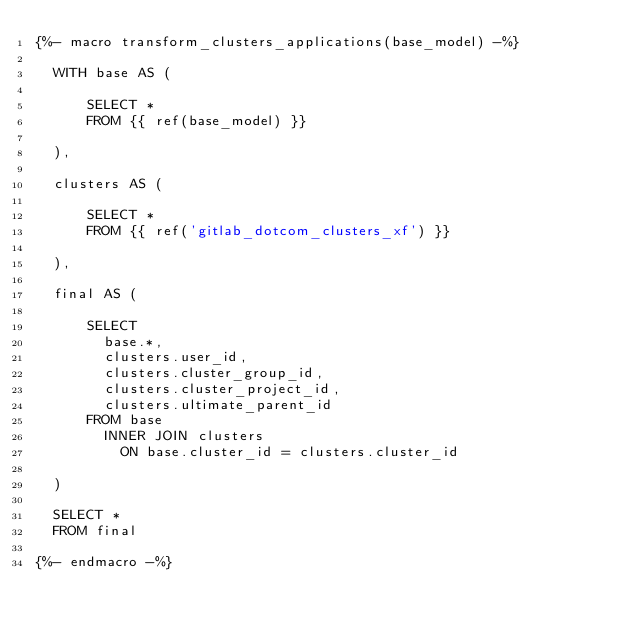Convert code to text. <code><loc_0><loc_0><loc_500><loc_500><_SQL_>{%- macro transform_clusters_applications(base_model) -%}

  WITH base AS (

      SELECT *
      FROM {{ ref(base_model) }}

  ),

  clusters AS (

      SELECT *
      FROM {{ ref('gitlab_dotcom_clusters_xf') }}

  ),

  final AS (

      SELECT
        base.*,
        clusters.user_id,
        clusters.cluster_group_id,
        clusters.cluster_project_id,
        clusters.ultimate_parent_id
      FROM base
        INNER JOIN clusters
          ON base.cluster_id = clusters.cluster_id

  )

  SELECT *
  FROM final

{%- endmacro -%}
</code> 